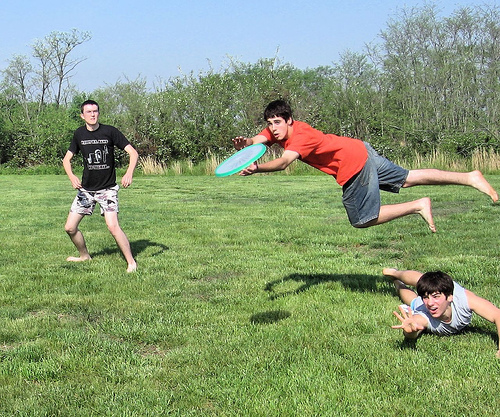Why do you think the boy is jumping so high? The boy is likely jumping high to catch the frisbee, demonstrating his agility and excitement during the game. Imagine the boy misses the frisbee. What might happen next? If the boy misses the frisbee, he might land on the ground safely and run after the frisbee to catch it on the next throw. The game would continue with all the boys enjoying their time outdoors. 